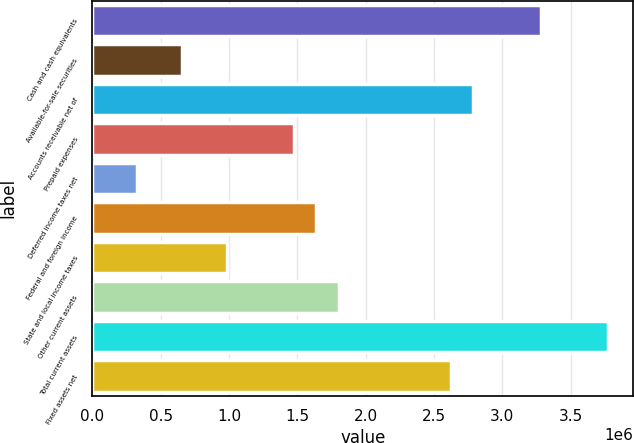<chart> <loc_0><loc_0><loc_500><loc_500><bar_chart><fcel>Cash and cash equivalents<fcel>Available-for-sale securities<fcel>Accounts receivable net of<fcel>Prepaid expenses<fcel>Deferred income taxes net<fcel>Federal and foreign income<fcel>State and local income taxes<fcel>Other current assets<fcel>Total current assets<fcel>Fixed assets net<nl><fcel>3.27906e+06<fcel>655921<fcel>2.78722e+06<fcel>1.47565e+06<fcel>328029<fcel>1.6396e+06<fcel>983812<fcel>1.80354e+06<fcel>3.77089e+06<fcel>2.62327e+06<nl></chart> 